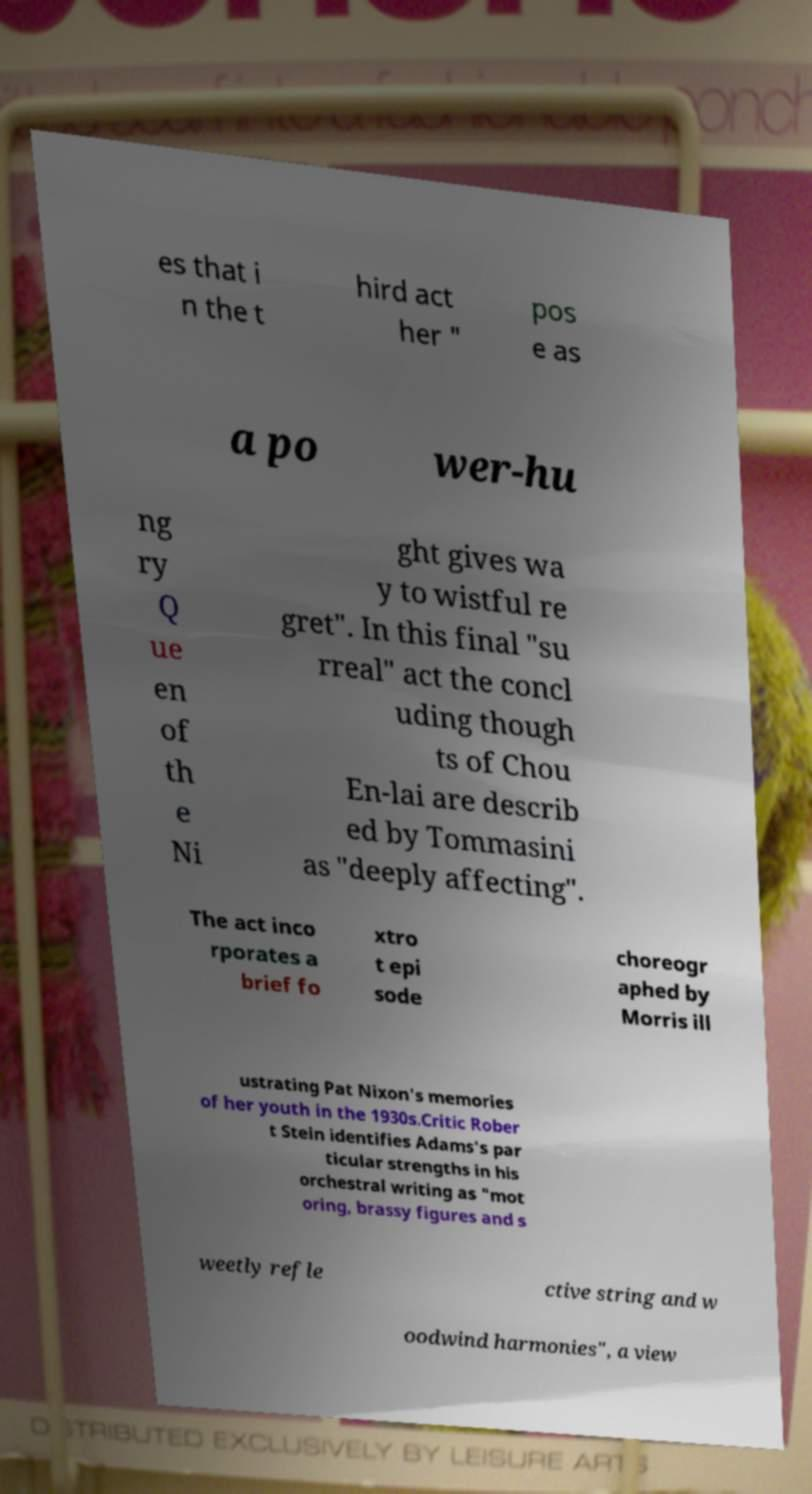Could you extract and type out the text from this image? es that i n the t hird act her " pos e as a po wer-hu ng ry Q ue en of th e Ni ght gives wa y to wistful re gret". In this final "su rreal" act the concl uding though ts of Chou En-lai are describ ed by Tommasini as "deeply affecting". The act inco rporates a brief fo xtro t epi sode choreogr aphed by Morris ill ustrating Pat Nixon's memories of her youth in the 1930s.Critic Rober t Stein identifies Adams's par ticular strengths in his orchestral writing as "mot oring, brassy figures and s weetly refle ctive string and w oodwind harmonies", a view 